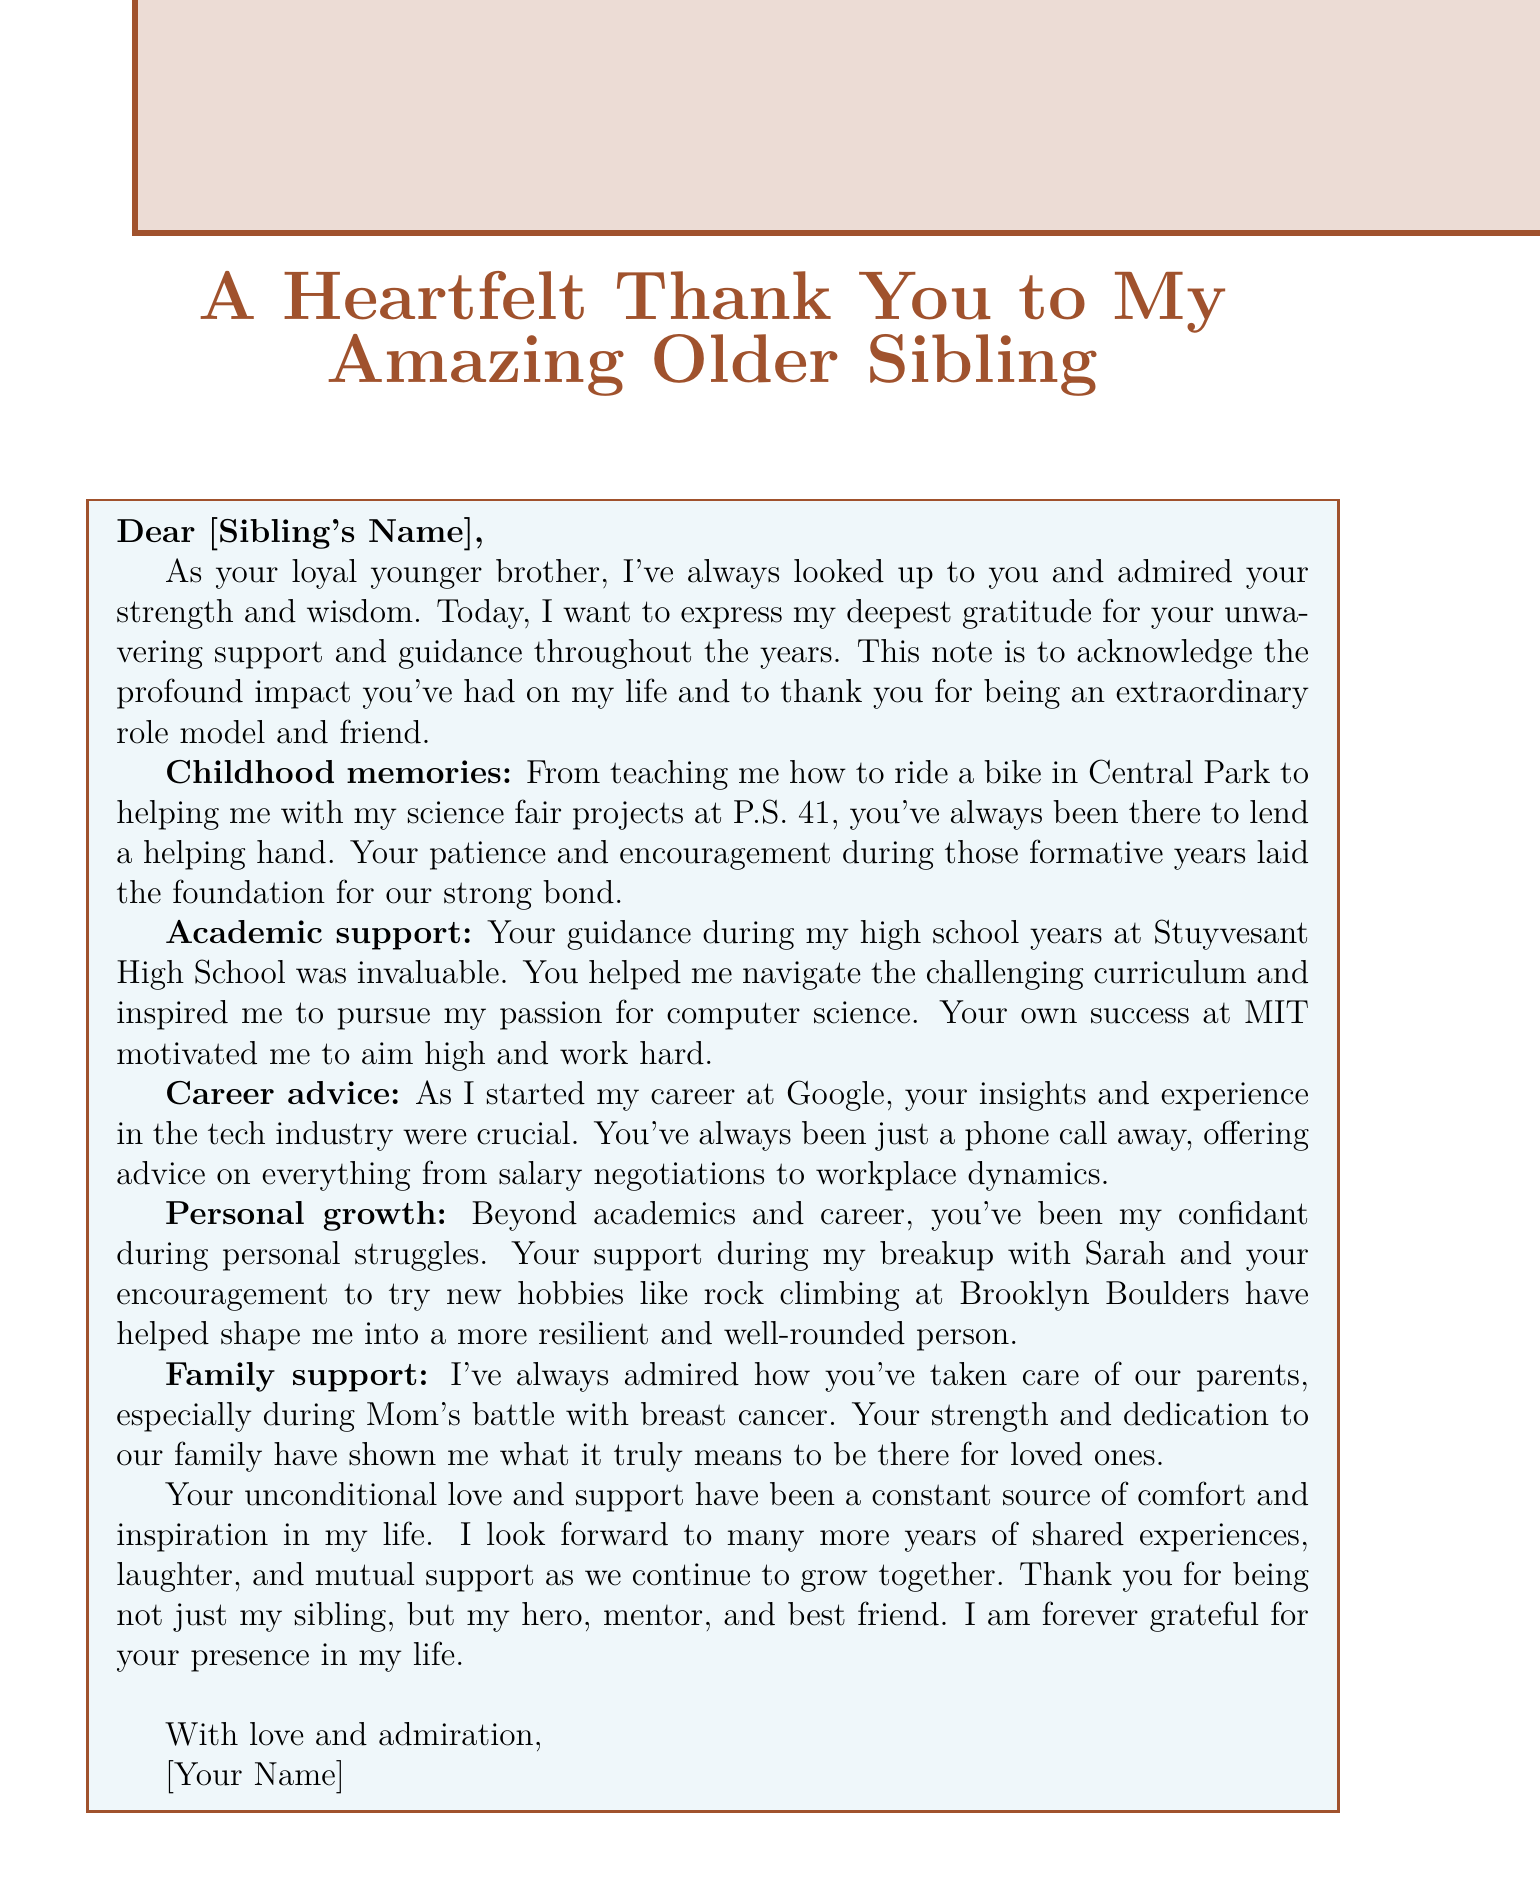What is the title of the memo? The title of the memo is stated at the beginning of the document.
Answer: A Heartfelt Thank You to My Amazing Older Sibling Who is the intended recipient of the memo? The memo is addressed to a specific person, identified as the sibling.
Answer: [Sibling's Name] What significant event does the memo mention regarding Mom? The document refers to a serious health issue affecting Mom, highlighting family support.
Answer: Breast cancer Which high school does the sender mention attending? The sender references their high school in the context of the guidance received.
Answer: Stuyvesant High School What sentiment does the sender express towards their older sibling? The overall tone of the memo conveys a deep feeling of appreciation.
Answer: Gratitude What profession does the sender mention starting? The sender discusses their career beginnings, indicating a specific workplace.
Answer: Google What hobby does the sender mention trying out? The document includes personal growth activities encouraged by the older sibling.
Answer: Rock climbing How does the sender feel about their older sibling's role in their life? The final thoughts in the memo summarize the sender's feelings towards their sibling's support.
Answer: Hero, mentor, and best friend 